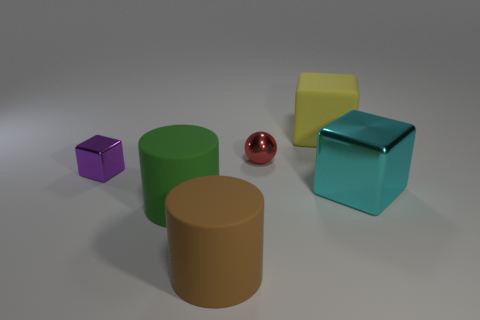Is there a yellow rubber cylinder that has the same size as the brown object?
Your answer should be very brief. No. Does the big cube that is behind the cyan metal block have the same color as the ball?
Provide a succinct answer. No. How many objects are either big shiny spheres or small purple things?
Provide a succinct answer. 1. There is a cube left of the red metal thing; is it the same size as the small sphere?
Your response must be concise. Yes. What is the size of the object that is left of the small metal ball and behind the large green cylinder?
Ensure brevity in your answer.  Small. How many other objects are the same shape as the tiny purple metal object?
Your response must be concise. 2. What number of other objects are the same material as the cyan thing?
Offer a very short reply. 2. There is another object that is the same shape as the green thing; what size is it?
Provide a short and direct response. Large. Is the color of the tiny block the same as the metal sphere?
Ensure brevity in your answer.  No. What color is the large matte object that is both in front of the red shiny object and behind the brown matte thing?
Your answer should be very brief. Green. 